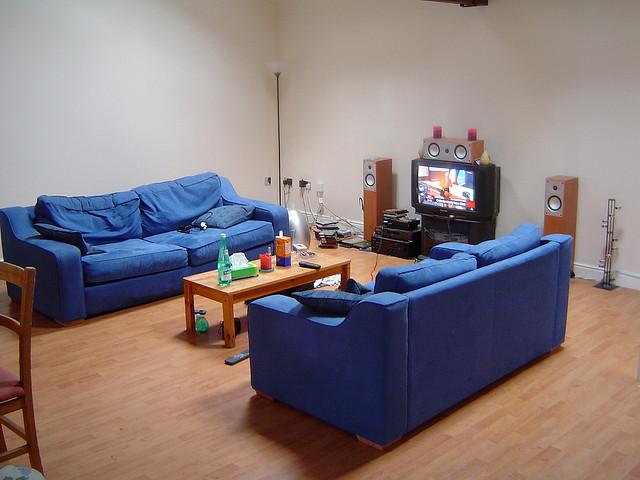What is the floor made of?
Be succinct. Wood. What color are these sofas?
Short answer required. Blue. Are there any speakers in the room?
Be succinct. Yes. Where are the remote controls?
Give a very brief answer. Table. 